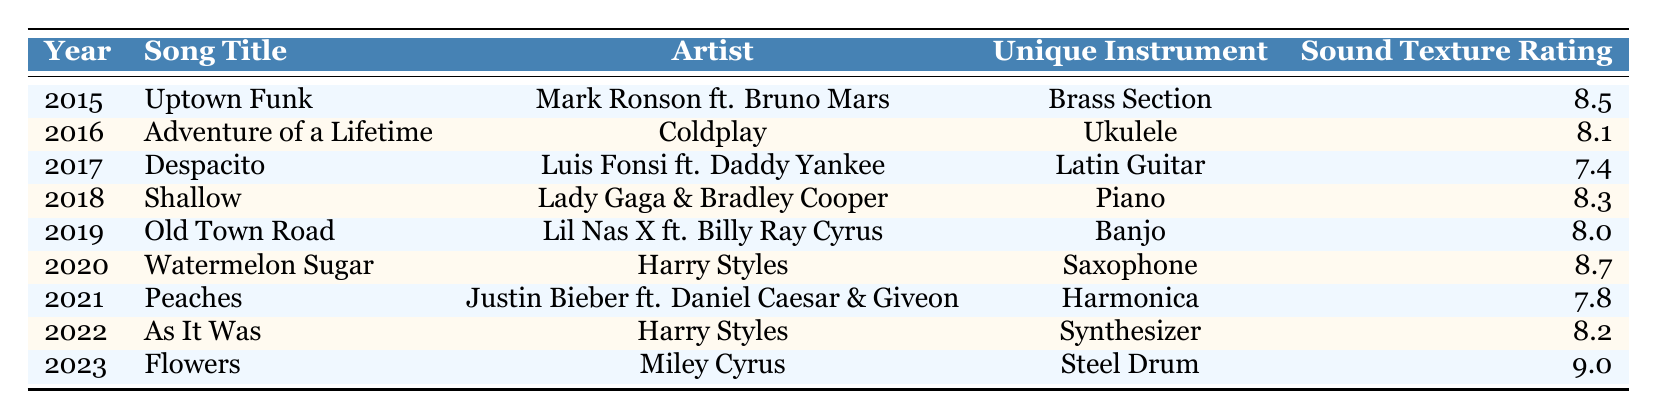What is the highest sound texture rating in the table? To find the highest sound texture rating, I will look at all the ratings listed. The values are: 8.5, 7.4, 8.0, 8.7, 7.8, 8.2, and 9.0. Among these, 9.0 is the highest.
Answer: 9.0 Which unique instrument appears in the song "Old Town Road"? The table lists the unique instrument for "Old Town Road" as "Banjo." I find this information in the corresponding row for the year 2019.
Answer: Banjo What is the average sound texture rating of the songs from 2016 to 2020? The ratings for the songs from 2016 to 2020 are 8.1, 7.4, 8.0, and 8.7. To calculate the average, I sum these values: (8.1 + 7.4 + 8.0 + 8.7) = 32.2. Then, I divide by the number of songs, which is 4: 32.2 / 4 = 8.05.
Answer: 8.05 Is there a song featuring a unique instrument rated above 9.0? The highest rating in the table is 9.0, associated with the song "Flowers." I will check if any ratings exceed this value, but there are none, confirming that 9.0 is the highest.
Answer: No What is the difference in sound texture rating between the highest and lowest rated songs? First, I identify the highest rating (9.0 for "Flowers") and the lowest rating (7.4 for "Despacito"). The difference is calculated as 9.0 - 7.4 = 1.6.
Answer: 1.6 Which unique instruments were used in songs from 2020 and 2021, and how do their ratings compare? The unique instrument for 2020 is "Saxophone" (rated 8.7) and for 2021 is "Harmonica" (rated 7.8). Comparing the two, 8.7 is higher than 7.8, indicating that "Saxophone" has a better sound texture rating than "Harmonica."
Answer: Saxophone is higher How many songs in the table have a sound texture rating of 8.0 or above? I will count the songs with ratings of 8.0 or higher: the ratings are 8.5, 8.1, 8.3, 8.0, 8.7, 8.2, and 9.0. This gives me a total of 7 songs that meet the criterion out of 9 listed.
Answer: 7 Which year has the lowest rated song featuring a unique instrument? Checking each year, I find "Despacito" for 2017 has the lowest rating, at 7.4. This is confirmed by looking at each song's rating in the table.
Answer: 2017 Can you list the songs featuring unique instruments rated above 8.5? The songs with ratings above 8.5 are "Uptown Funk" (8.5 is not above), "Watermelon Sugar" (8.7), and "Flowers" (9.0). Thus, the qualifying songs are just these two.
Answer: Watermelon Sugar, Flowers 